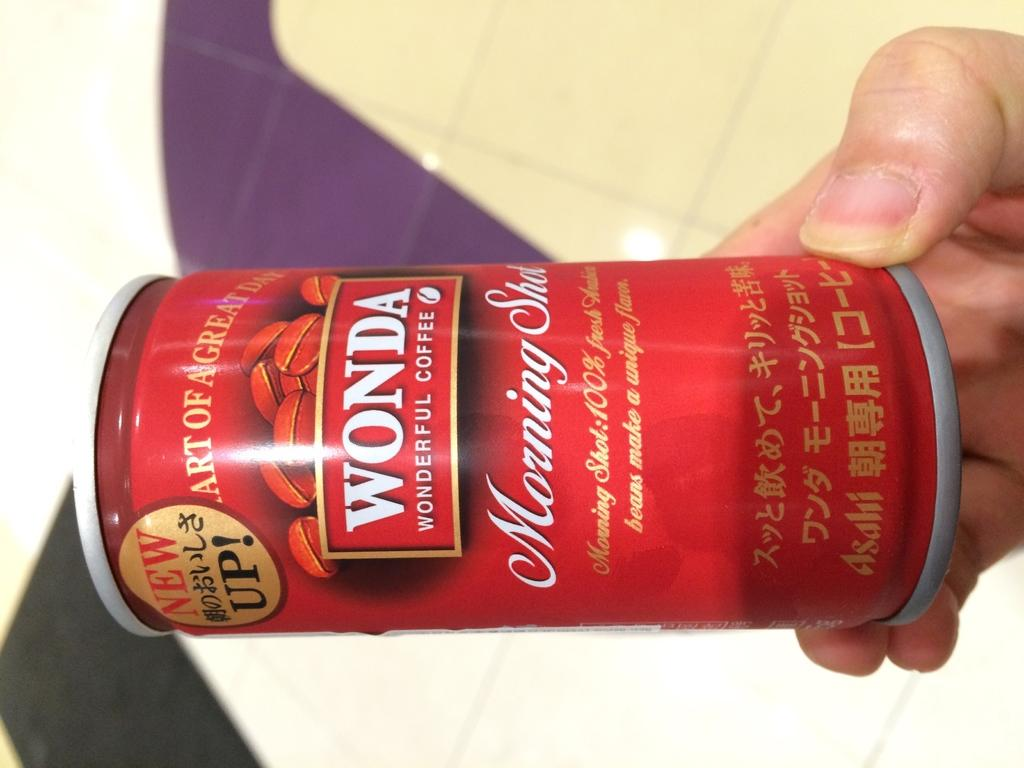<image>
Write a terse but informative summary of the picture. A person holding a red can of Wonda Wonderful shot. 